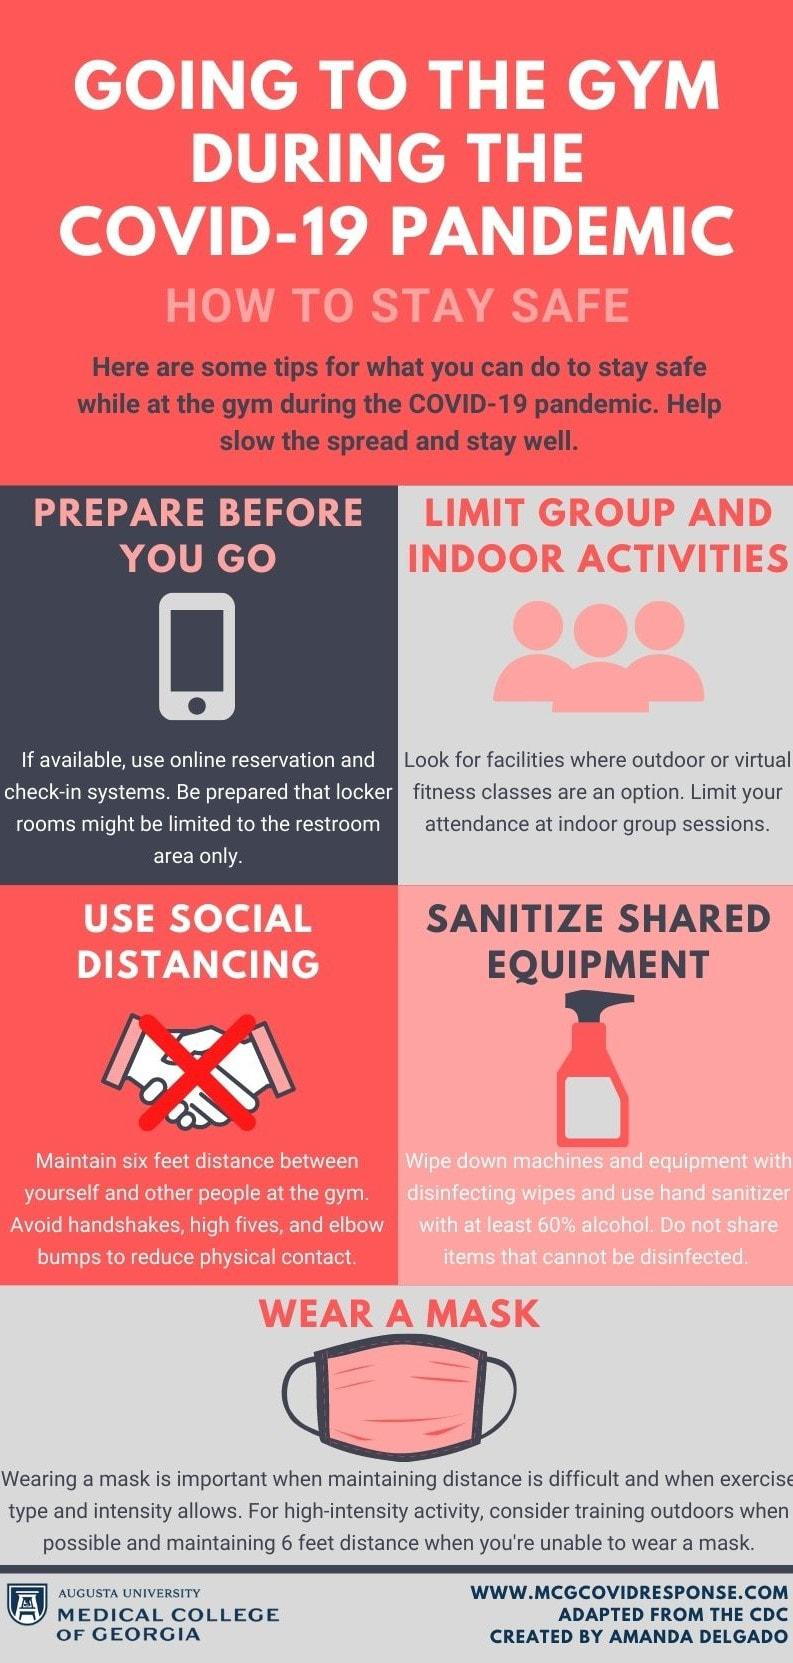Draw attention to some important aspects in this diagram. This infographic contains only one mask. 